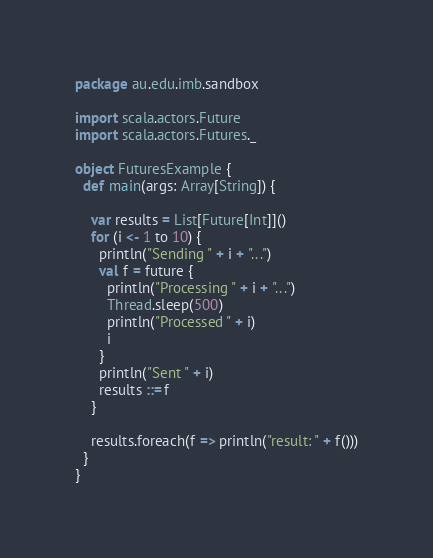<code> <loc_0><loc_0><loc_500><loc_500><_Scala_>package au.edu.imb.sandbox

import scala.actors.Future
import scala.actors.Futures._

object FuturesExample {
  def main(args: Array[String]) {

    var results = List[Future[Int]]()
    for (i <- 1 to 10) {
      println("Sending " + i + "...")
      val f = future {
        println("Processing " + i + "...")
        Thread.sleep(500)
        println("Processed " + i)
        i
      }
      println("Sent " + i)
      results ::= f
    }

    results.foreach(f => println("result: " + f()))
  }
}</code> 